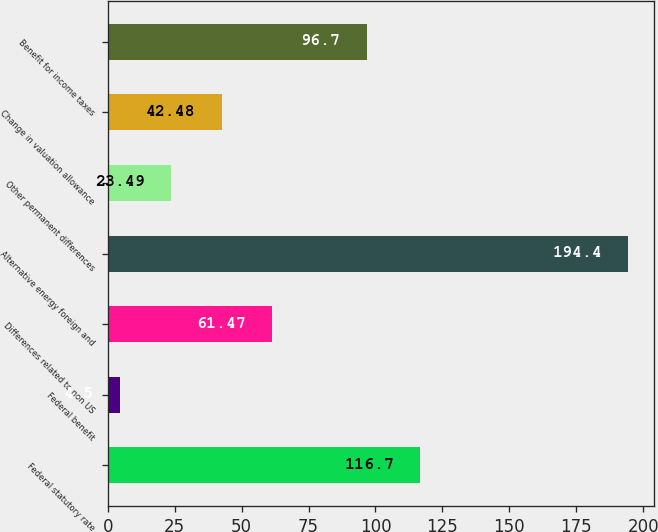<chart> <loc_0><loc_0><loc_500><loc_500><bar_chart><fcel>Federal statutory rate<fcel>Federal benefit<fcel>Differences related to non US<fcel>Alternative energy foreign and<fcel>Other permanent differences<fcel>Change in valuation allowance<fcel>Benefit for income taxes<nl><fcel>116.7<fcel>4.5<fcel>61.47<fcel>194.4<fcel>23.49<fcel>42.48<fcel>96.7<nl></chart> 